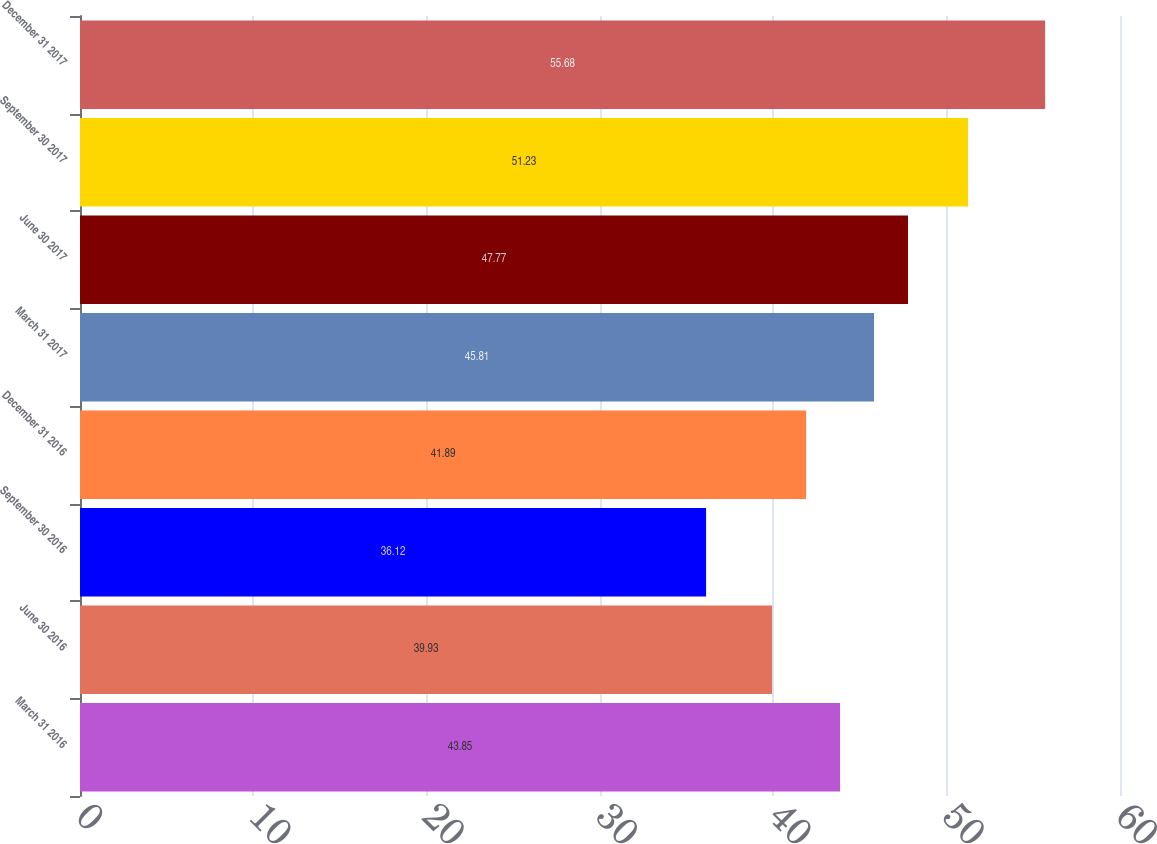Convert chart. <chart><loc_0><loc_0><loc_500><loc_500><bar_chart><fcel>March 31 2016<fcel>June 30 2016<fcel>September 30 2016<fcel>December 31 2016<fcel>March 31 2017<fcel>June 30 2017<fcel>September 30 2017<fcel>December 31 2017<nl><fcel>43.85<fcel>39.93<fcel>36.12<fcel>41.89<fcel>45.81<fcel>47.77<fcel>51.23<fcel>55.68<nl></chart> 